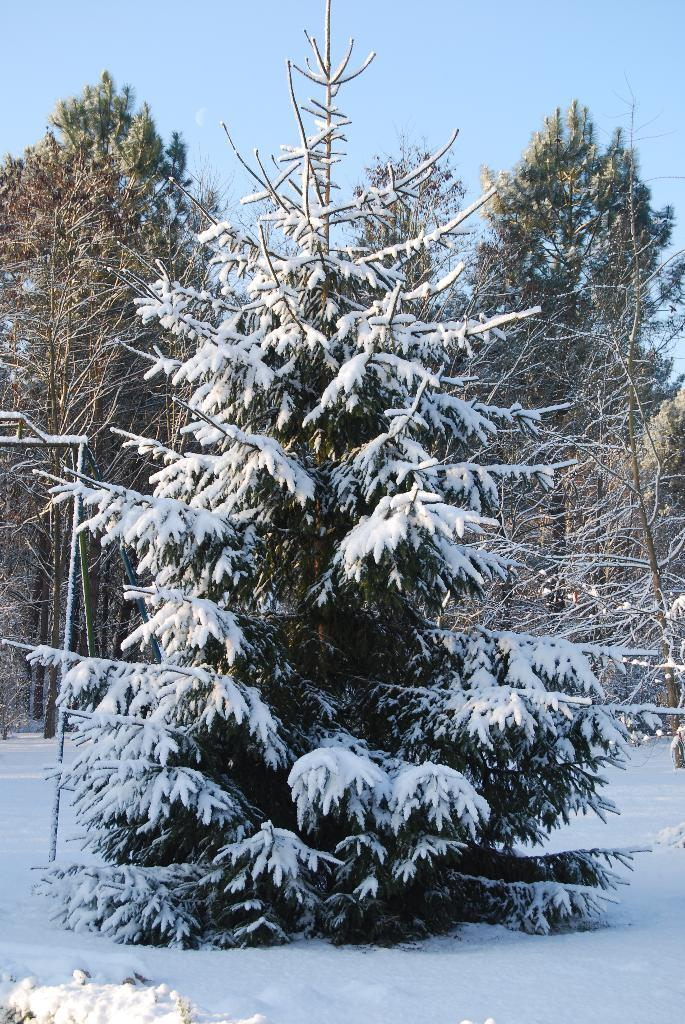What type of vegetation is present in the image? There is a group of trees in the image. What is covering the trees in the image? The trees are covered with snow. What other object can be seen in the image? There is a pole in the image. What is visible in the background of the image? The sky is visible in the image. How would you describe the sky in the image? The sky looks cloudy in the image. Can you tell me which actor is biting the iron in the image? There are no actors or iron present in the image; it features a group of snow-covered trees, a pole, and a cloudy sky. 